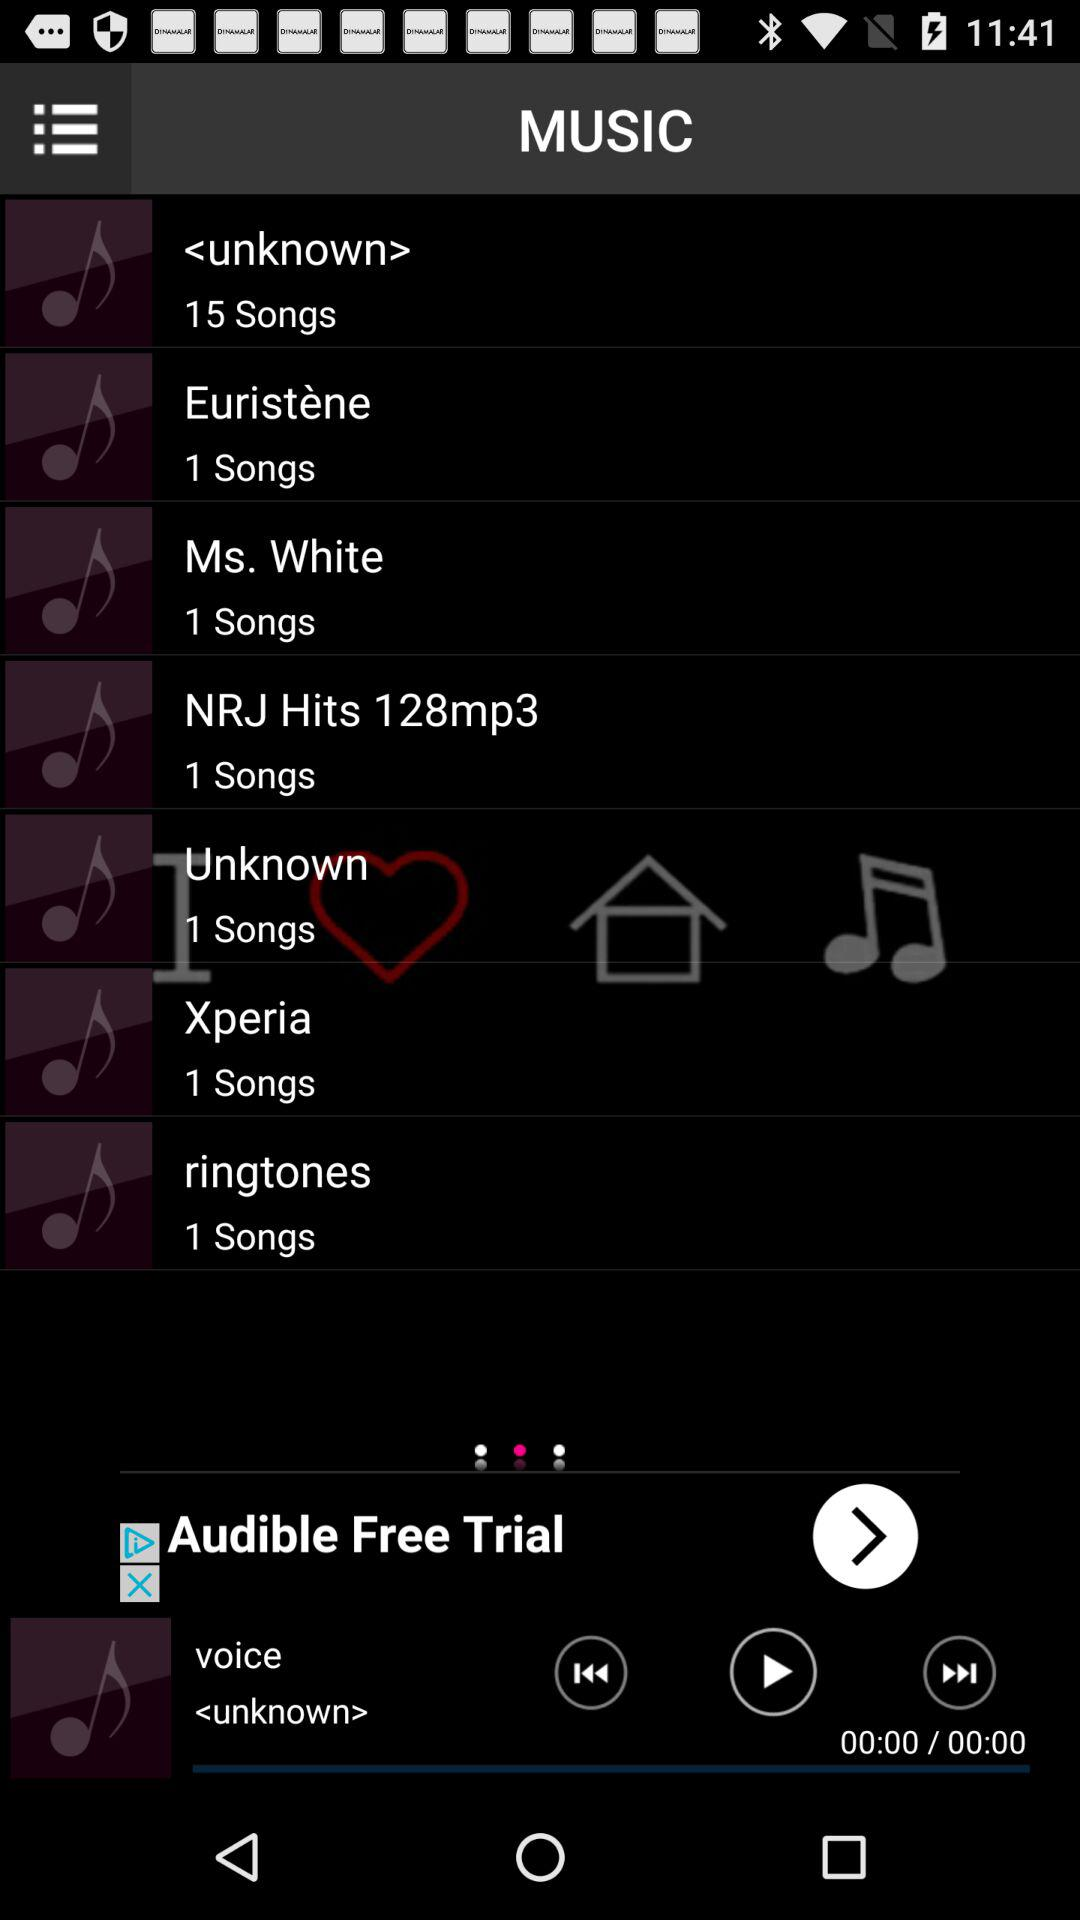How many songs are in the "Xperia" album? There is 1 song in the "Xperia" album. 